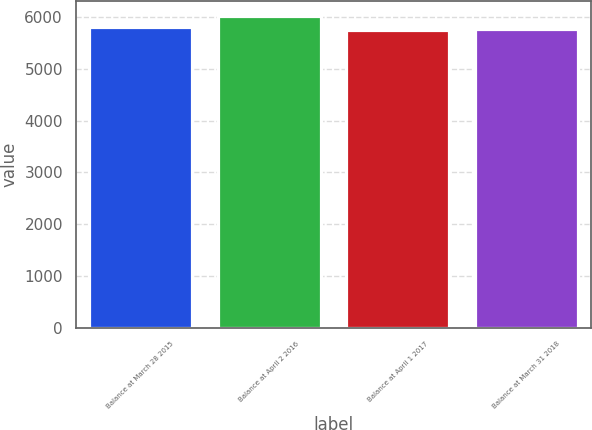<chart> <loc_0><loc_0><loc_500><loc_500><bar_chart><fcel>Balance at March 28 2015<fcel>Balance at April 2 2016<fcel>Balance at April 1 2017<fcel>Balance at March 31 2018<nl><fcel>5804.52<fcel>6015<fcel>5751.9<fcel>5778.21<nl></chart> 